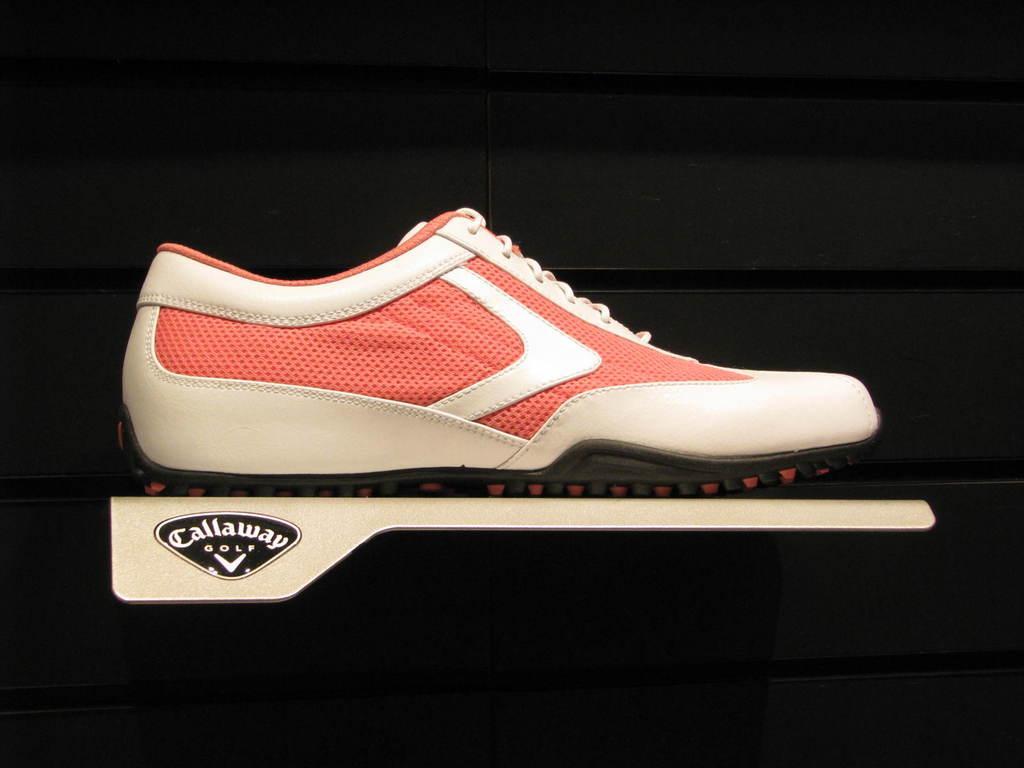Please provide a concise description of this image. In this image we can see a shoe on the metal surface and black background. 